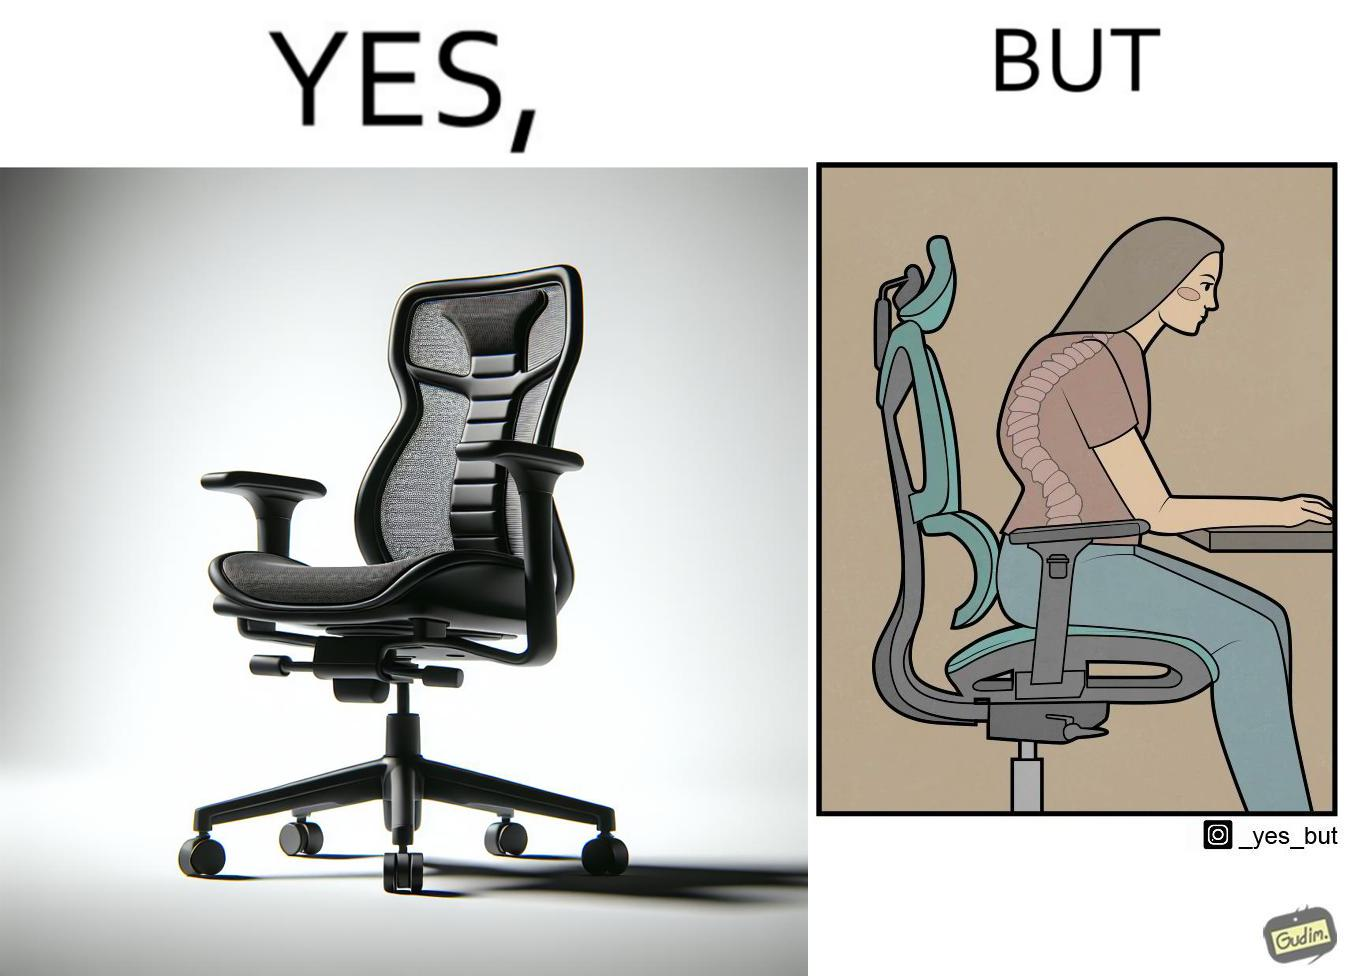What is shown in this image? The image is ironical, as even though the ergonomic chair is meant to facilitate an upright and comfortable posture for the person sitting on it, the person sitting on it still has a bent posture, as the person is not utilizing the backrest. 